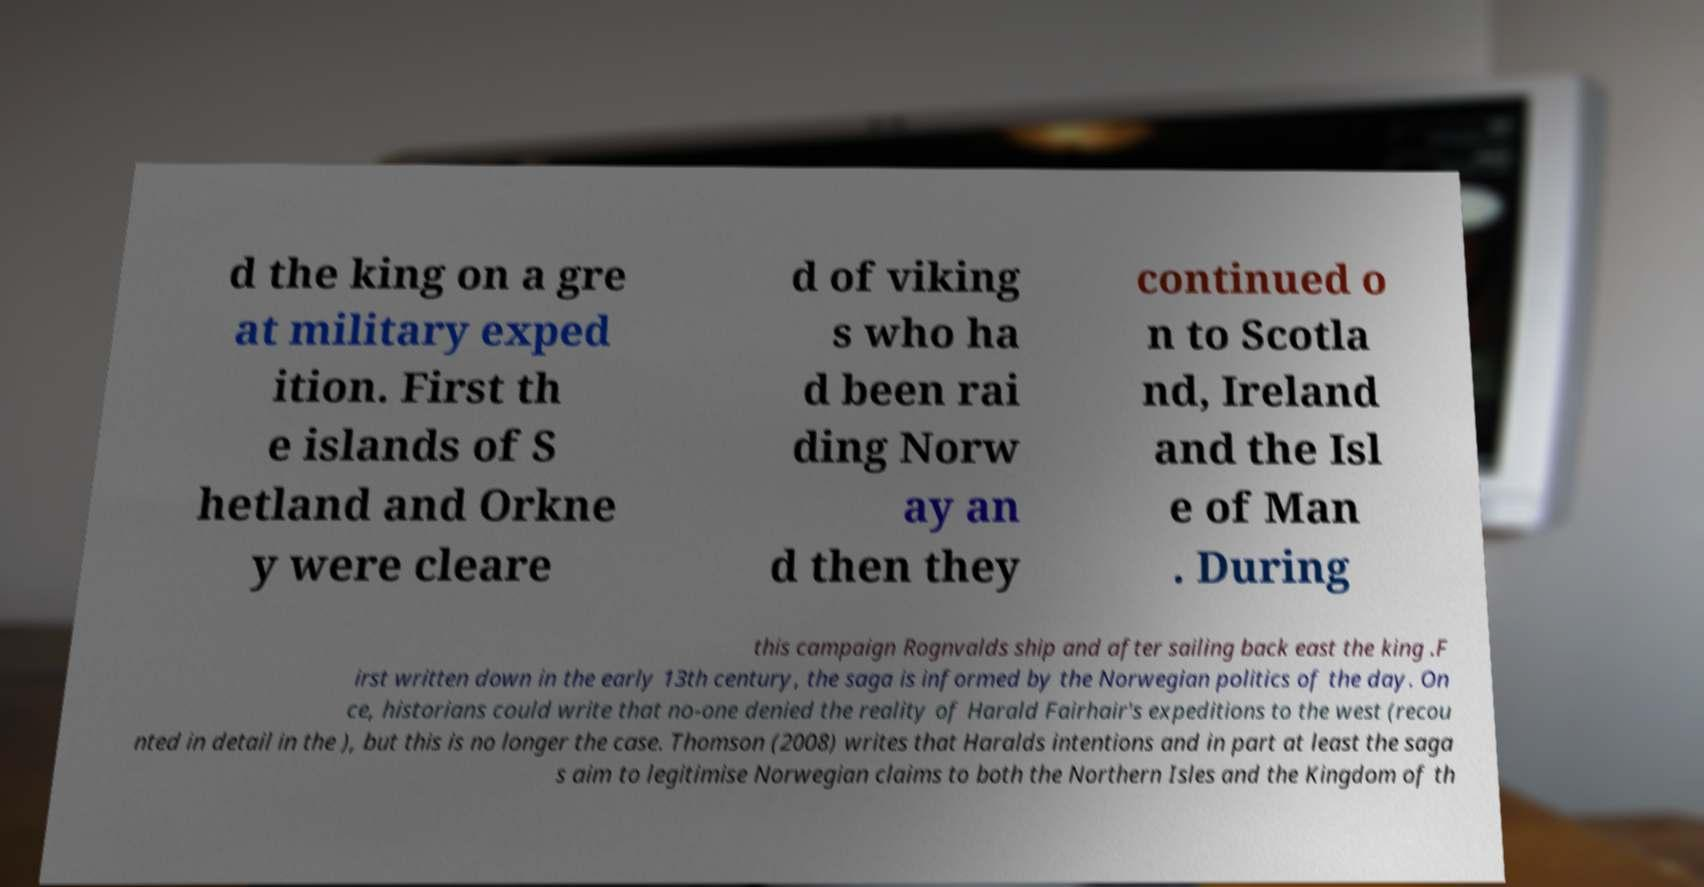Could you extract and type out the text from this image? d the king on a gre at military exped ition. First th e islands of S hetland and Orkne y were cleare d of viking s who ha d been rai ding Norw ay an d then they continued o n to Scotla nd, Ireland and the Isl e of Man . During this campaign Rognvalds ship and after sailing back east the king .F irst written down in the early 13th century, the saga is informed by the Norwegian politics of the day. On ce, historians could write that no-one denied the reality of Harald Fairhair's expeditions to the west (recou nted in detail in the ), but this is no longer the case. Thomson (2008) writes that Haralds intentions and in part at least the saga s aim to legitimise Norwegian claims to both the Northern Isles and the Kingdom of th 